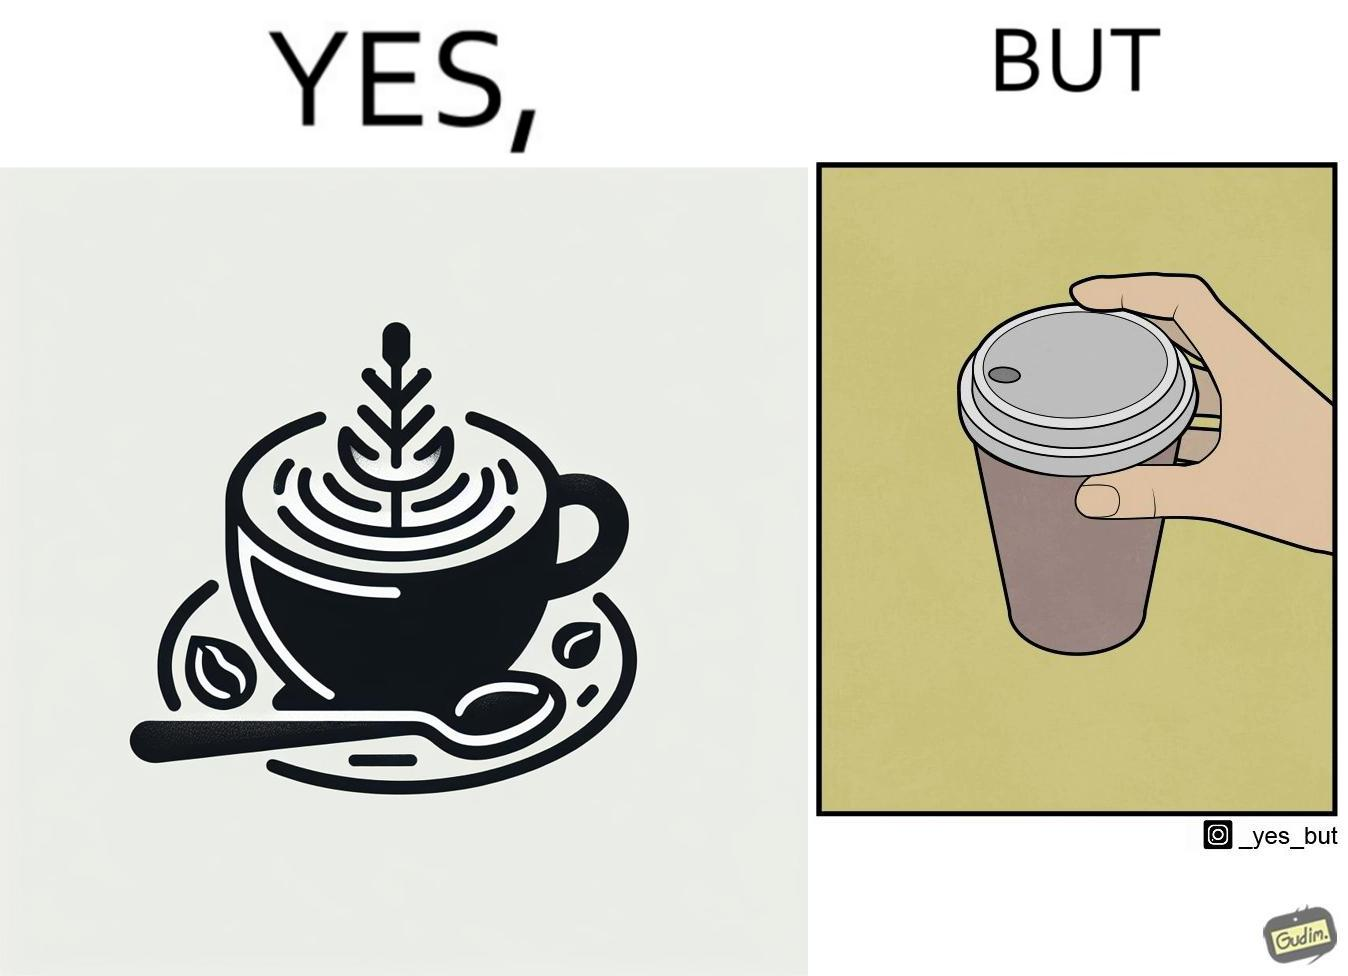Does this image contain satire or humor? Yes, this image is satirical. 